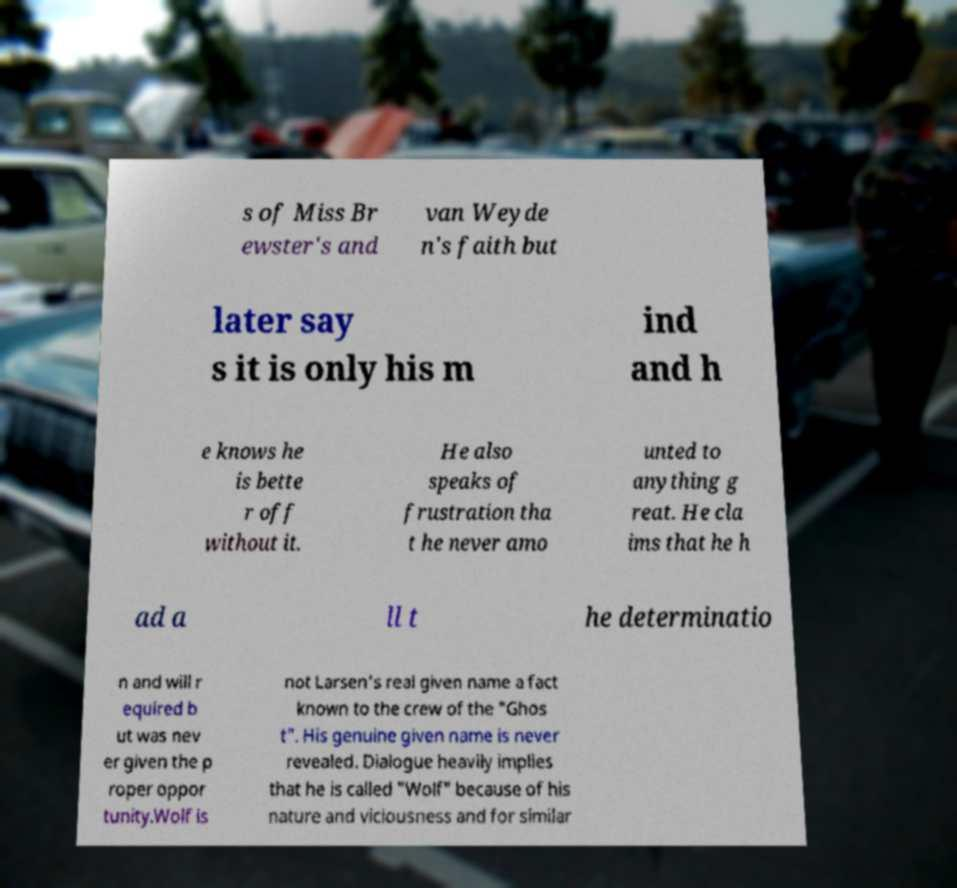I need the written content from this picture converted into text. Can you do that? s of Miss Br ewster's and van Weyde n's faith but later say s it is only his m ind and h e knows he is bette r off without it. He also speaks of frustration tha t he never amo unted to anything g reat. He cla ims that he h ad a ll t he determinatio n and will r equired b ut was nev er given the p roper oppor tunity.Wolf is not Larsen's real given name a fact known to the crew of the "Ghos t". His genuine given name is never revealed. Dialogue heavily implies that he is called "Wolf" because of his nature and viciousness and for similar 